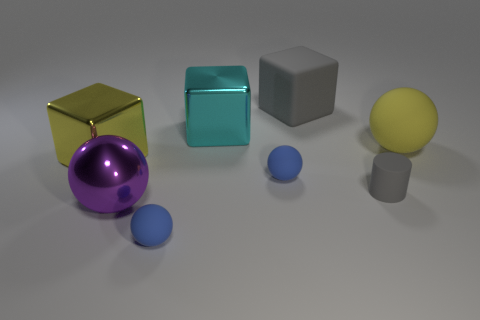Subtract all cyan cylinders. Subtract all gray balls. How many cylinders are left? 1 Add 2 purple objects. How many objects exist? 10 Subtract all blocks. How many objects are left? 5 Subtract all cubes. Subtract all green metal cubes. How many objects are left? 5 Add 6 big metal balls. How many big metal balls are left? 7 Add 6 big gray things. How many big gray things exist? 7 Subtract 0 red blocks. How many objects are left? 8 